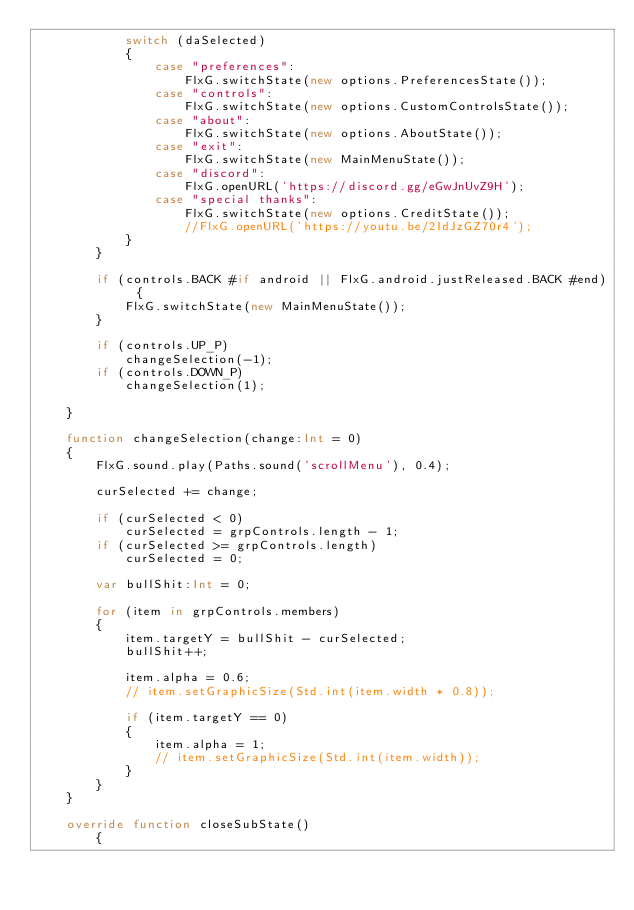<code> <loc_0><loc_0><loc_500><loc_500><_Haxe_>			switch (daSelected)
			{
				case "preferences":
					FlxG.switchState(new options.PreferencesState());
				case "controls":
					FlxG.switchState(new options.CustomControlsState());
				case "about":
					FlxG.switchState(new options.AboutState());
				case "exit":
					FlxG.switchState(new MainMenuState());
				case "discord":
					FlxG.openURL('https://discord.gg/eGwJnUvZ9H');
				case "special thanks":
					FlxG.switchState(new options.CreditState());
					//FlxG.openURL('https://youtu.be/2IdJzGZ70r4');
			}
		}

		if (controls.BACK #if android || FlxG.android.justReleased.BACK #end) {
			FlxG.switchState(new MainMenuState());
		}

		if (controls.UP_P)
			changeSelection(-1);
		if (controls.DOWN_P)
			changeSelection(1);

	}

	function changeSelection(change:Int = 0)
	{
		FlxG.sound.play(Paths.sound('scrollMenu'), 0.4);

		curSelected += change;

		if (curSelected < 0)
			curSelected = grpControls.length - 1;
		if (curSelected >= grpControls.length)
			curSelected = 0;

		var bullShit:Int = 0;

		for (item in grpControls.members)
		{
			item.targetY = bullShit - curSelected;
			bullShit++;

			item.alpha = 0.6;
			// item.setGraphicSize(Std.int(item.width * 0.8));

			if (item.targetY == 0)
			{
				item.alpha = 1;
				// item.setGraphicSize(Std.int(item.width));
			}
		}
	}

	override function closeSubState()
		{</code> 